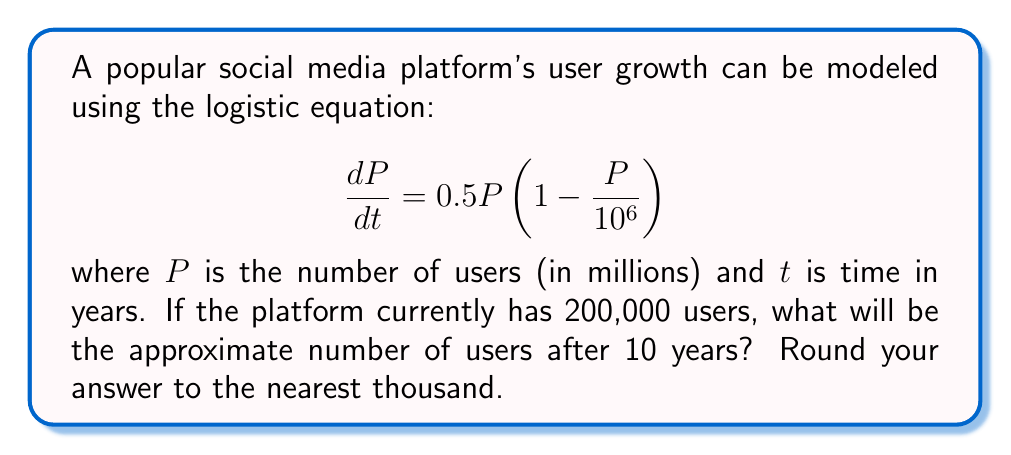Can you answer this question? To solve this problem, we need to use the logistic growth model and its solution. The general form of the logistic equation is:

$$\frac{dP}{dt} = rP(1 - \frac{P}{K})$$

where $r$ is the growth rate and $K$ is the carrying capacity.

In our case, $r = 0.5$ and $K = 10^6$ (1 million users).

The solution to the logistic equation is:

$$P(t) = \frac{K}{1 + (\frac{K}{P_0} - 1)e^{-rt}}$$

where $P_0$ is the initial population.

Step 1: Calculate $P_0$ in millions
$P_0 = 200,000 / 10^6 = 0.2$ million users

Step 2: Substitute the values into the solution equation
$$P(10) = \frac{10^6}{1 + (\frac{10^6}{0.2} - 1)e^{-0.5 \cdot 10}}$$

Step 3: Simplify and calculate
$$P(10) = \frac{10^6}{1 + (5 \times 10^6 - 1)e^{-5}}$$
$$P(10) = \frac{10^6}{1 + 4999999 \cdot 0.006737}$$
$$P(10) = \frac{10^6}{1 + 33683.32}$$
$$P(10) = \frac{10^6}{33684.32}$$
$$P(10) \approx 29,687.53$$

Step 4: Convert back to actual users and round to the nearest thousand
$29,687.53 \times 10^3 \approx 29,688,000$ users
Answer: 29,688,000 users 